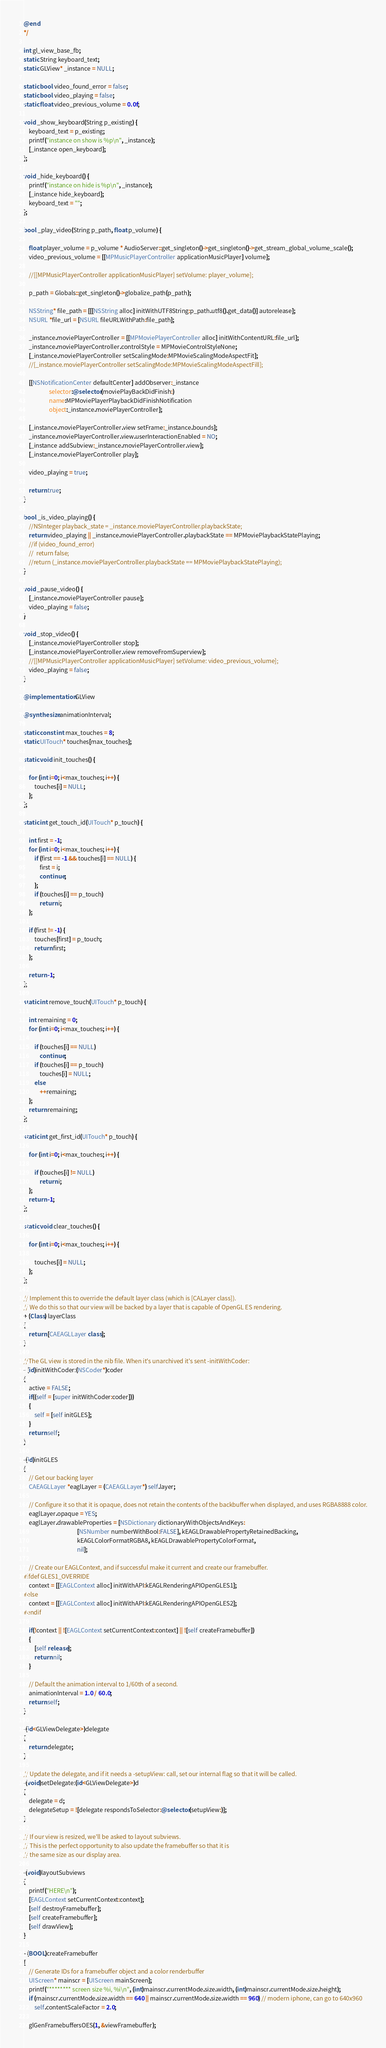<code> <loc_0><loc_0><loc_500><loc_500><_ObjectiveC_>@end
*/

int gl_view_base_fb;
static String keyboard_text;
static GLView* _instance = NULL;

static bool video_found_error = false;
static bool video_playing = false;
static float video_previous_volume = 0.0f;

void _show_keyboard(String p_existing) {
	keyboard_text = p_existing;
	printf("instance on show is %p\n", _instance);
	[_instance open_keyboard];
};

void _hide_keyboard() {
	printf("instance on hide is %p\n", _instance);
	[_instance hide_keyboard];
	keyboard_text = "";
};

bool _play_video(String p_path, float p_volume) {
	
	float player_volume = p_volume * AudioServer::get_singleton()->get_singleton()->get_stream_global_volume_scale();
	video_previous_volume = [[MPMusicPlayerController applicationMusicPlayer] volume];

	//[[MPMusicPlayerController applicationMusicPlayer] setVolume: player_volume];

	p_path = Globals::get_singleton()->globalize_path(p_path);

	NSString* file_path = [[[NSString alloc] initWithUTF8String:p_path.utf8().get_data()] autorelease];
	NSURL *file_url = [NSURL fileURLWithPath:file_path];
		
	_instance.moviePlayerController = [[MPMoviePlayerController alloc] initWithContentURL:file_url];
	_instance.moviePlayerController.controlStyle = MPMovieControlStyleNone;
	[_instance.moviePlayerController setScalingMode:MPMovieScalingModeAspectFit];
	//[_instance.moviePlayerController setScalingMode:MPMovieScalingModeAspectFill];
	
	[[NSNotificationCenter defaultCenter] addObserver:_instance
                   selector:@selector(moviePlayBackDidFinish:)
                   name:MPMoviePlayerPlaybackDidFinishNotification
                   object:_instance.moviePlayerController];
	
	[_instance.moviePlayerController.view setFrame:_instance.bounds];
	_instance.moviePlayerController.view.userInteractionEnabled = NO;
	[_instance addSubview:_instance.moviePlayerController.view];
	[_instance.moviePlayerController play];

	video_playing = true;

	return true;
}

bool _is_video_playing() {
	//NSInteger playback_state = _instance.moviePlayerController.playbackState;
	return video_playing || _instance.moviePlayerController.playbackState == MPMoviePlaybackStatePlaying;
	//if (video_found_error)
	//	return false;
	//return (_instance.moviePlayerController.playbackState == MPMoviePlaybackStatePlaying);
}

void _pause_video() {
	[_instance.moviePlayerController pause];
	video_playing = false;
}

void _stop_video() {
	[_instance.moviePlayerController stop];
	[_instance.moviePlayerController.view removeFromSuperview];
	//[[MPMusicPlayerController applicationMusicPlayer] setVolume: video_previous_volume];
	video_playing = false;
}

@implementation GLView

@synthesize animationInterval;

static const int max_touches = 8;
static UITouch* touches[max_touches];

static void init_touches() {

	for (int i=0; i<max_touches; i++) {
		touches[i] = NULL;
	};
};

static int get_touch_id(UITouch* p_touch) {

	int first = -1;
	for (int i=0; i<max_touches; i++) {
		if (first == -1 && touches[i] == NULL) {
			first = i;
			continue;
		};
		if (touches[i] == p_touch)
			return i;
	};

	if (first != -1) {
		touches[first] = p_touch;
		return first;
	};

	return -1;
};

static int remove_touch(UITouch* p_touch) {

	int remaining = 0;
	for (int i=0; i<max_touches; i++) {

		if (touches[i] == NULL)
			continue;
		if (touches[i] == p_touch)
			touches[i] = NULL;
		else
			++remaining;
	};
	return remaining;
};

static int get_first_id(UITouch* p_touch) {

	for (int i=0; i<max_touches; i++) {

		if (touches[i] != NULL)
			return i;
	};
	return -1;
};

static void clear_touches() {

	for (int i=0; i<max_touches; i++) {

		touches[i] = NULL;
	};
};

// Implement this to override the default layer class (which is [CALayer class]).
// We do this so that our view will be backed by a layer that is capable of OpenGL ES rendering.
+ (Class) layerClass
{
	return [CAEAGLLayer class];
}

//The GL view is stored in the nib file. When it's unarchived it's sent -initWithCoder:
- (id)initWithCoder:(NSCoder*)coder
{
	active = FALSE;
	if((self = [super initWithCoder:coder]))
	{
		self = [self initGLES];
	}	
	return self;
}

-(id)initGLES
{
	// Get our backing layer
	CAEAGLLayer *eaglLayer = (CAEAGLLayer*) self.layer;
	
	// Configure it so that it is opaque, does not retain the contents of the backbuffer when displayed, and uses RGBA8888 color.
	eaglLayer.opaque = YES;
	eaglLayer.drawableProperties = [NSDictionary dictionaryWithObjectsAndKeys:
										[NSNumber numberWithBool:FALSE], kEAGLDrawablePropertyRetainedBacking,
										kEAGLColorFormatRGBA8, kEAGLDrawablePropertyColorFormat,
										nil];
	
	// Create our EAGLContext, and if successful make it current and create our framebuffer.
#ifdef GLES1_OVERRIDE
	context = [[EAGLContext alloc] initWithAPI:kEAGLRenderingAPIOpenGLES1];
#else
	context = [[EAGLContext alloc] initWithAPI:kEAGLRenderingAPIOpenGLES2];
#endif

	if(!context || ![EAGLContext setCurrentContext:context] || ![self createFramebuffer])
	{
		[self release];
		return nil;
	}
	
	// Default the animation interval to 1/60th of a second.
	animationInterval = 1.0 / 60.0;
	return self;
}

-(id<GLViewDelegate>)delegate
{
	return delegate;
}

// Update the delegate, and if it needs a -setupView: call, set our internal flag so that it will be called.
-(void)setDelegate:(id<GLViewDelegate>)d
{
	delegate = d;
	delegateSetup = ![delegate respondsToSelector:@selector(setupView:)];
}

// If our view is resized, we'll be asked to layout subviews.
// This is the perfect opportunity to also update the framebuffer so that it is
// the same size as our display area.

-(void)layoutSubviews
{
	printf("HERE\n");
	[EAGLContext setCurrentContext:context];
	[self destroyFramebuffer];
	[self createFramebuffer];
	[self drawView];
}

- (BOOL)createFramebuffer
{
	// Generate IDs for a framebuffer object and a color renderbuffer
	UIScreen* mainscr = [UIScreen mainScreen];
	printf("******** screen size %i, %i\n", (int)mainscr.currentMode.size.width, (int)mainscr.currentMode.size.height);
	if (mainscr.currentMode.size.width == 640 || mainscr.currentMode.size.width == 960) // modern iphone, can go to 640x960
		self.contentScaleFactor = 2.0;

	glGenFramebuffersOES(1, &viewFramebuffer);</code> 